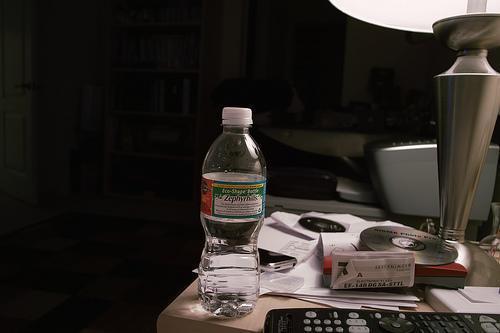How many bottle are there?
Give a very brief answer. 1. 